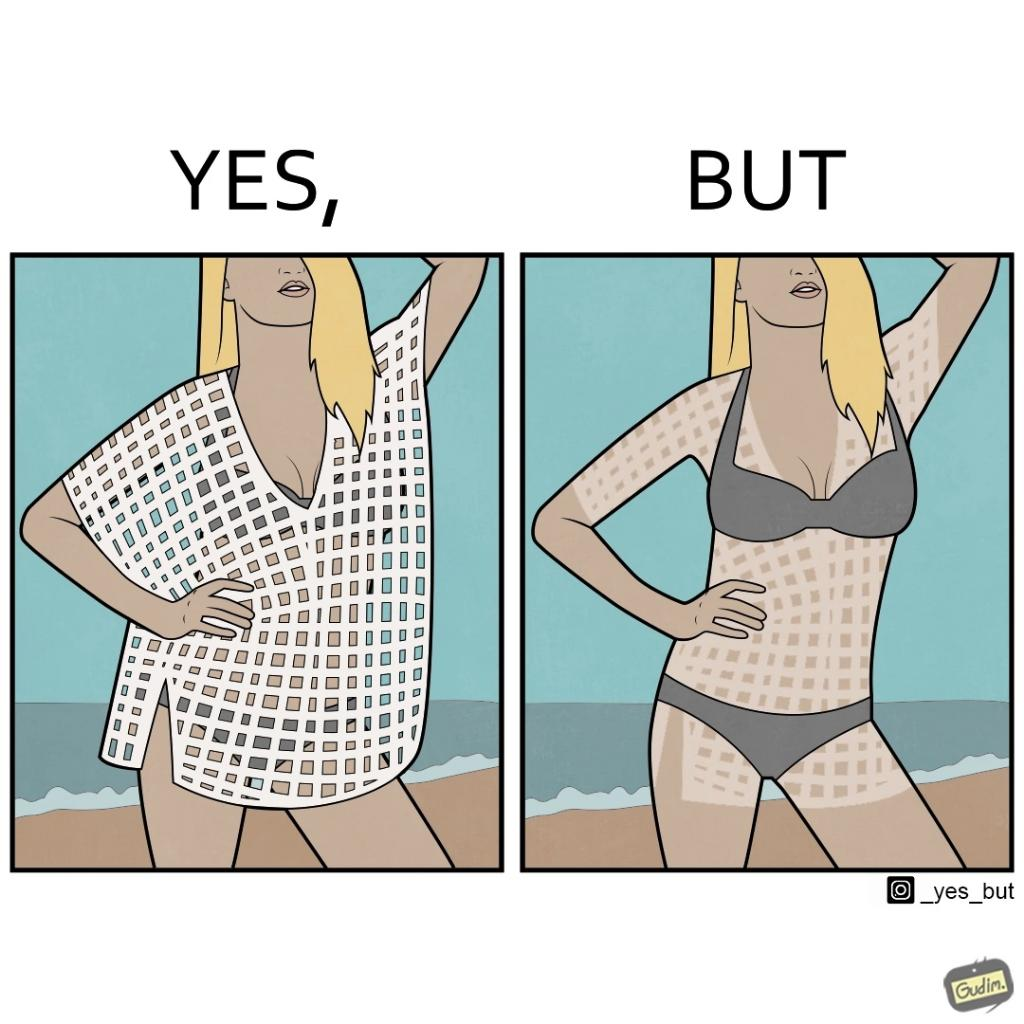Compare the left and right sides of this image. In the left part of the image: a woman wearing a netted top over bikini posing for some photo at beach In the right part of the image: a woman wearing bikini, with tanned body in some spots, posing for some photo at beach 